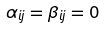<formula> <loc_0><loc_0><loc_500><loc_500>\alpha _ { i j } = \beta _ { i j } = 0</formula> 